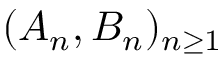<formula> <loc_0><loc_0><loc_500><loc_500>( A _ { n } , B _ { n } ) _ { n \geq 1 }</formula> 